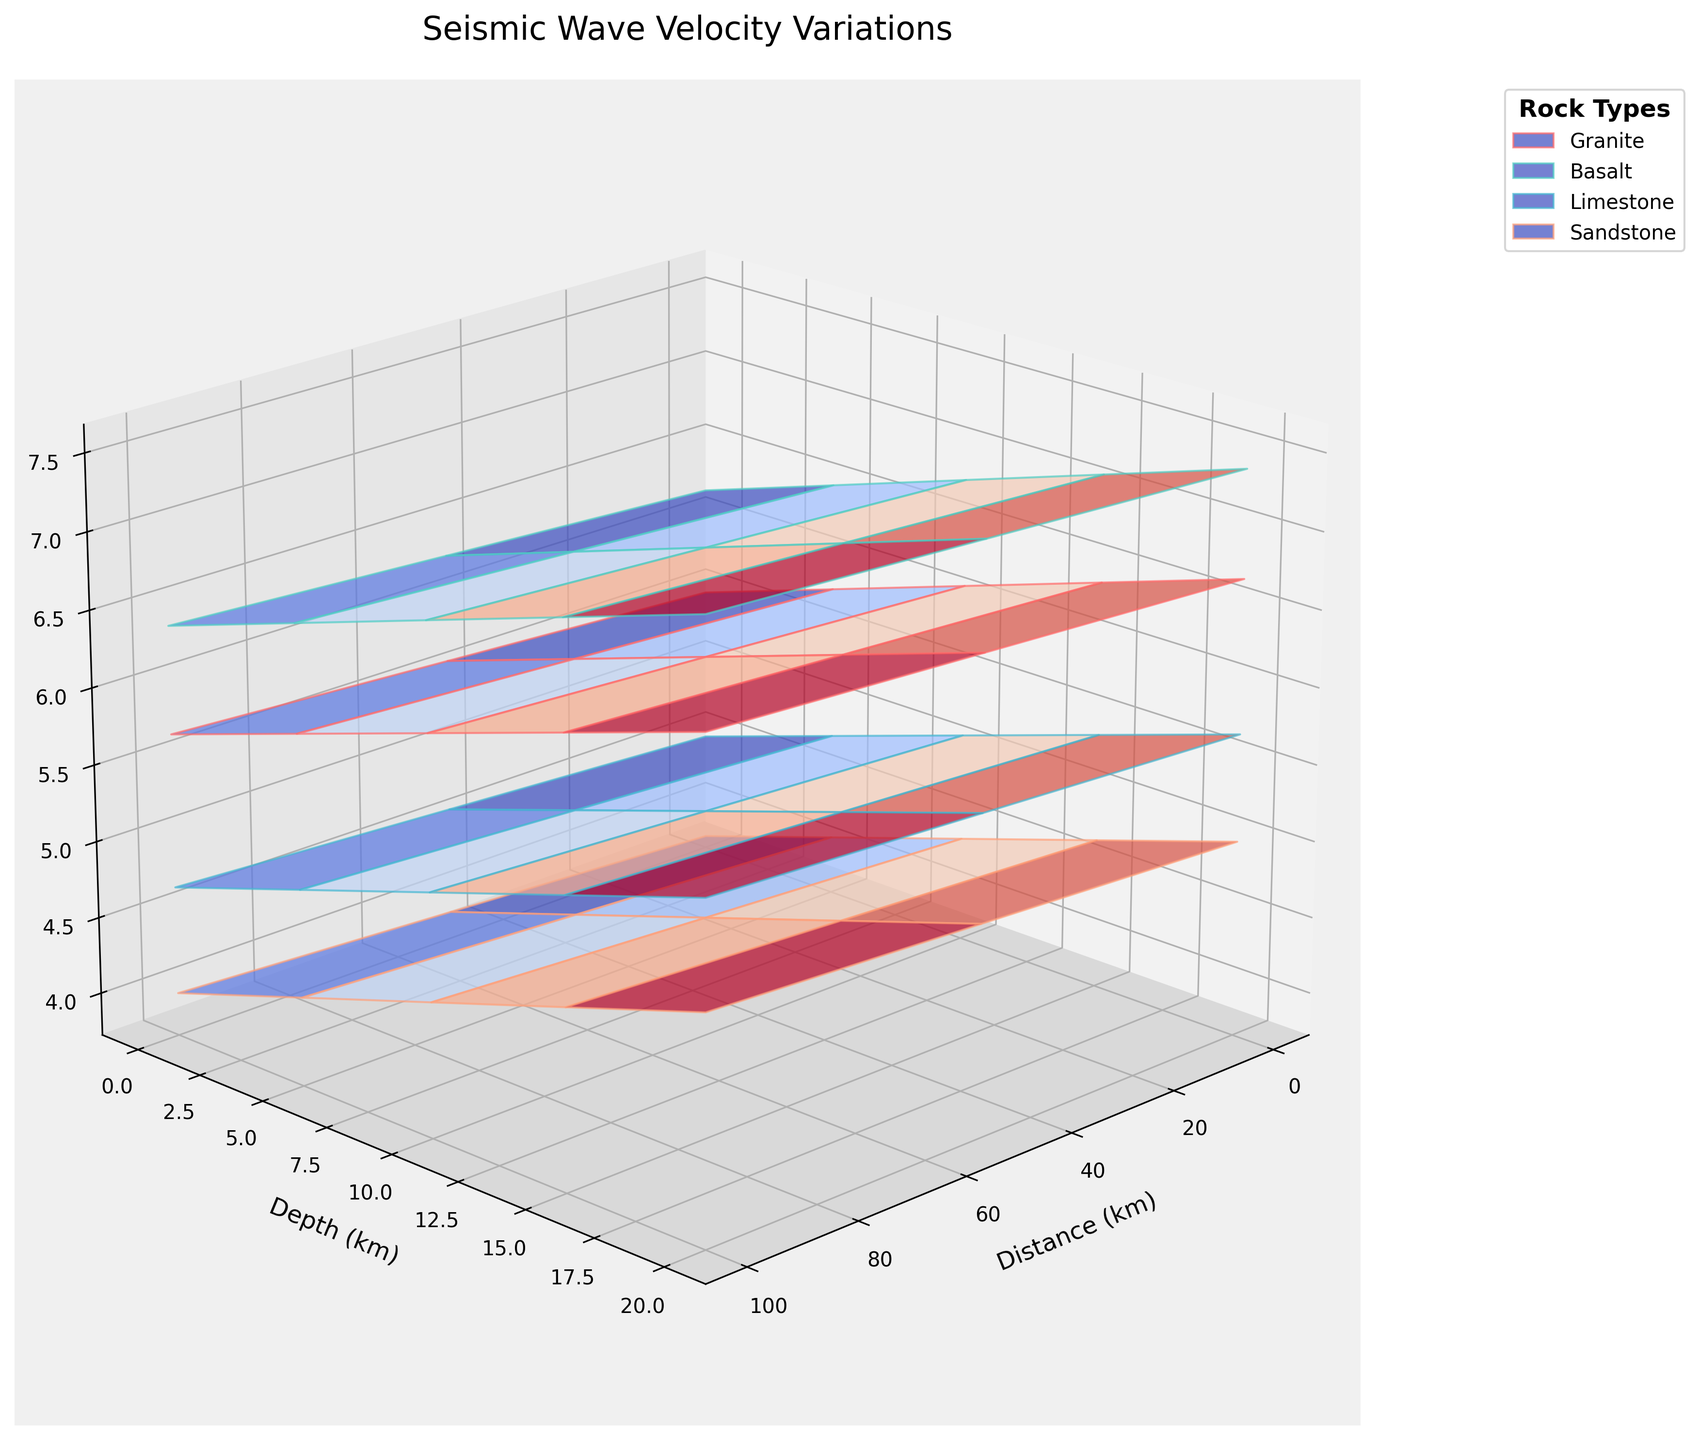What is the title of the plot? The title of the plot is displayed at the top of the graph, above the axes and the plotted surfaces. Here, it is labeled as "Seismic Wave Velocity Variations".
Answer: Seismic Wave Velocity Variations What is represented on the Z-axis? The label on the Z-axis specifies what it represents, which in this plot is "Velocity (km/s)".
Answer: Velocity (km/s) How does the seismic wave velocity in granite change with increasing depth? By observing the surface corresponding to granite, we can see that as the depth increases, the velocity in granite also consistently increases.
Answer: Increases At a depth of 10 km, which rock type has the highest seismic wave velocity? At a depth of 10 km, comparing the velocities of all rock types by examining their respective surfaces, basalt shows the highest velocity.
Answer: Basalt How does the seismic wave velocity in sandstone change with increasing distance from the source? Observing the surface corresponding to sandstone, we can see that the velocity gradually increases as the distance from the source increases.
Answer: Increases Between basalt and limestone, which rock type shows a greater increase in seismic wave velocity from 0 km to 10 km depth? By examining the surfaces corresponding to basalt and limestone, basalt has a larger range of increase in seismic wave velocity from 0 km to 10 km depth compared to limestone.
Answer: Basalt What is the approximate seismic wave velocity in limestone at a depth of 20 km and a distance of 50 km from the source? Locate the point on the limestone surface that corresponds to a depth of 20 km and a distance of 50 km from the source. The Z-value at this point represents the velocity, which is approximately 5.8 km/s.
Answer: 5.8 km/s At a depth of 15 km, how much greater is the seismic wave velocity in basalt compared to sandstone at a distance of 100 km from the source? At 15 km depth and 100 km distance, the velocities for basalt and sandstone are 7.3 km/s and 4.9 km/s, respectively. The difference is 7.3 - 4.9 = 2.4 km/s.
Answer: 2.4 km/s Which rock type has the smallest rate of change in seismic wave velocity with depth? By comparing the slopes of the surfaces in the Z direction (depth) for all rock types, sandstone shows the smallest rate of change in seismic wave velocity with depth.
Answer: Sandstone How does the seismic wave velocity in granite vary with both depth and distance? Observing the surface for granite, the velocity increases with both increases in depth and distance from the source.
Answer: Increases 